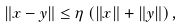<formula> <loc_0><loc_0><loc_500><loc_500>\left \| x - y \right \| \leq \eta \left ( \left \| x \right \| + \left \| y \right \| \right ) ,</formula> 